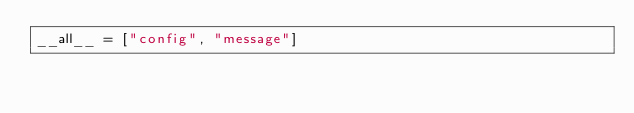Convert code to text. <code><loc_0><loc_0><loc_500><loc_500><_Python_>__all__ = ["config", "message"]
</code> 